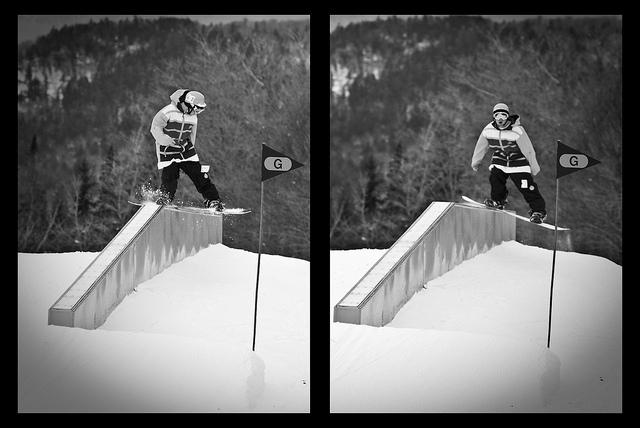What wintertime activity is this man doing?
Write a very short answer. Snowboarding. Are these images identical?
Be succinct. No. What letter is on the flag?
Quick response, please. G. 